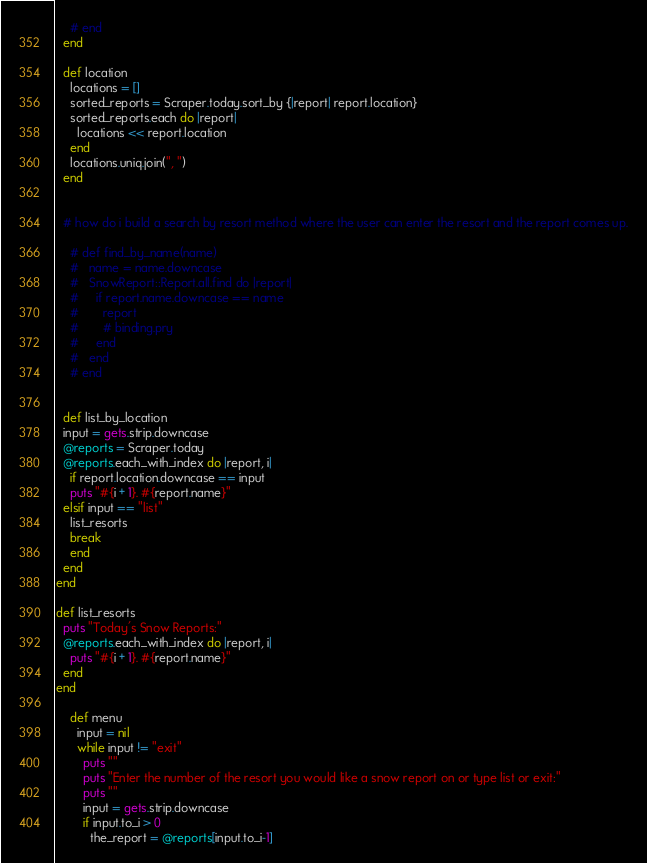Convert code to text. <code><loc_0><loc_0><loc_500><loc_500><_Ruby_>    # end
  end

  def location
    locations = []
    sorted_reports = Scraper.today.sort_by {|report| report.location}
    sorted_reports.each do |report|
      locations << report.location
    end
    locations.uniq.join(", ")
  end


  # how do i build a search by resort method where the user can enter the resort and the report comes up.

    # def find_by_name(name)
    #   name = name.downcase
    #   SnowReport::Report.all.find do |report|
    #     if report.name.downcase == name
    #       report
    #       # binding.pry
    #     end
    #   end
    # end


  def list_by_location
  input = gets.strip.downcase
  @reports = Scraper.today
  @reports.each_with_index do |report, i|
    if report.location.downcase == input
    puts "#{i + 1}. #{report.name}"
  elsif input == "list"
    list_resorts
    break
    end
  end
end

def list_resorts
  puts "Today's Snow Reports:"
  @reports.each_with_index do |report, i|
    puts "#{i + 1}. #{report.name}"
  end
end

    def menu
      input = nil
      while input != "exit"
        puts ""
        puts "Enter the number of the resort you would like a snow report on or type list or exit:"
        puts ""
        input = gets.strip.downcase
        if input.to_i > 0
          the_report = @reports[input.to_i-1]</code> 